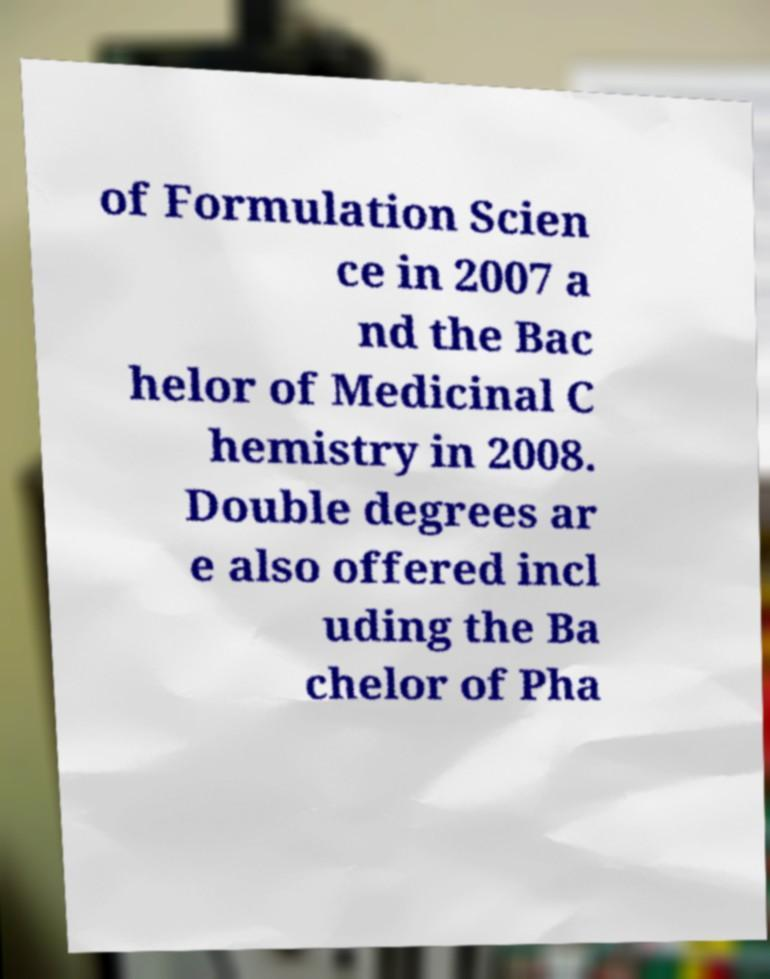Can you read and provide the text displayed in the image?This photo seems to have some interesting text. Can you extract and type it out for me? of Formulation Scien ce in 2007 a nd the Bac helor of Medicinal C hemistry in 2008. Double degrees ar e also offered incl uding the Ba chelor of Pha 